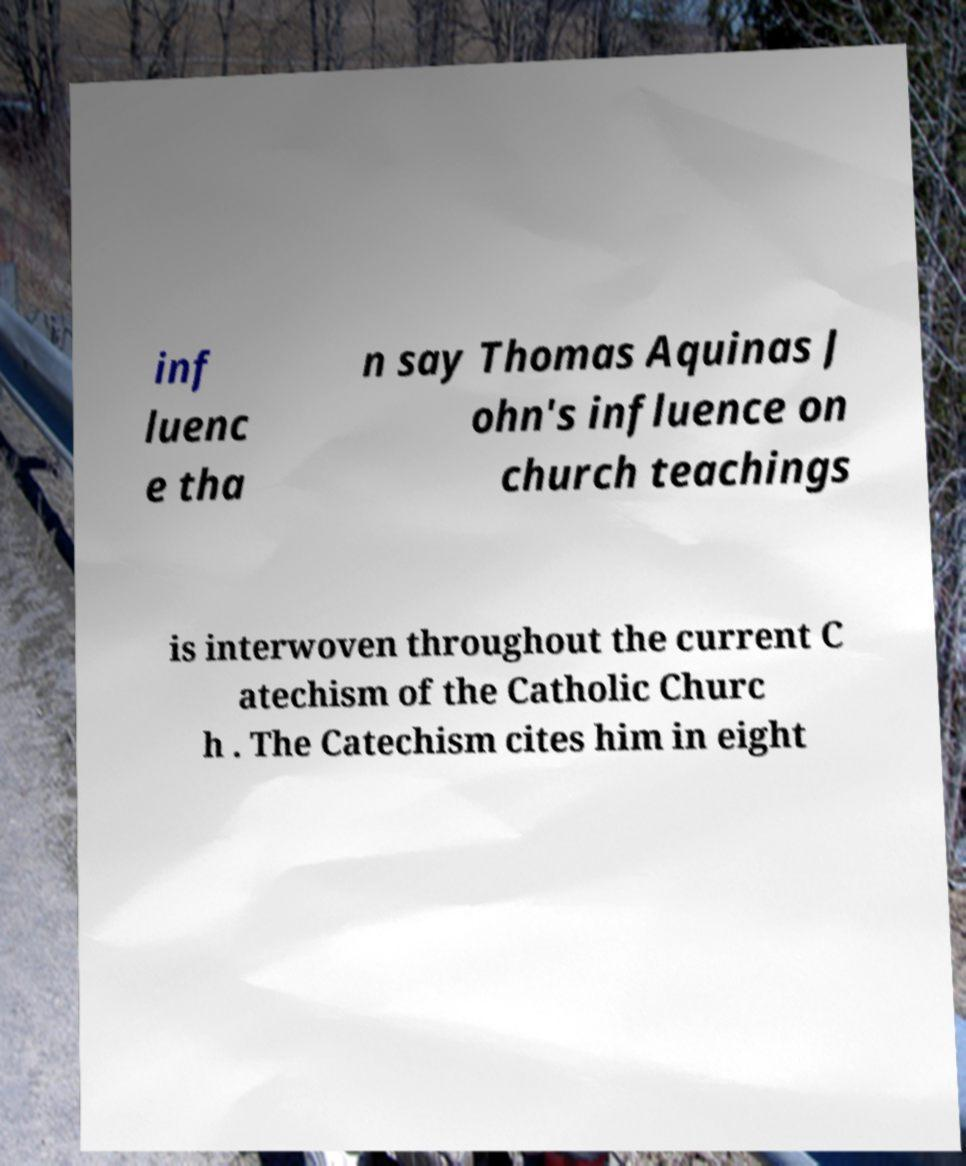What messages or text are displayed in this image? I need them in a readable, typed format. inf luenc e tha n say Thomas Aquinas J ohn's influence on church teachings is interwoven throughout the current C atechism of the Catholic Churc h . The Catechism cites him in eight 